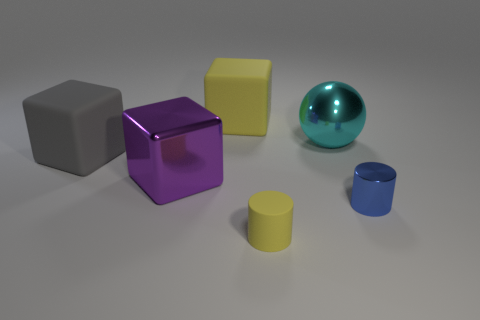Add 1 small objects. How many objects exist? 7 Subtract all shiny blocks. How many blocks are left? 2 Subtract 1 gray blocks. How many objects are left? 5 Subtract all cylinders. How many objects are left? 4 Subtract 1 cubes. How many cubes are left? 2 Subtract all gray cylinders. Subtract all cyan balls. How many cylinders are left? 2 Subtract all blue blocks. How many gray balls are left? 0 Subtract all large purple shiny things. Subtract all large yellow matte blocks. How many objects are left? 4 Add 6 large gray matte objects. How many large gray matte objects are left? 7 Add 6 large blue cubes. How many large blue cubes exist? 6 